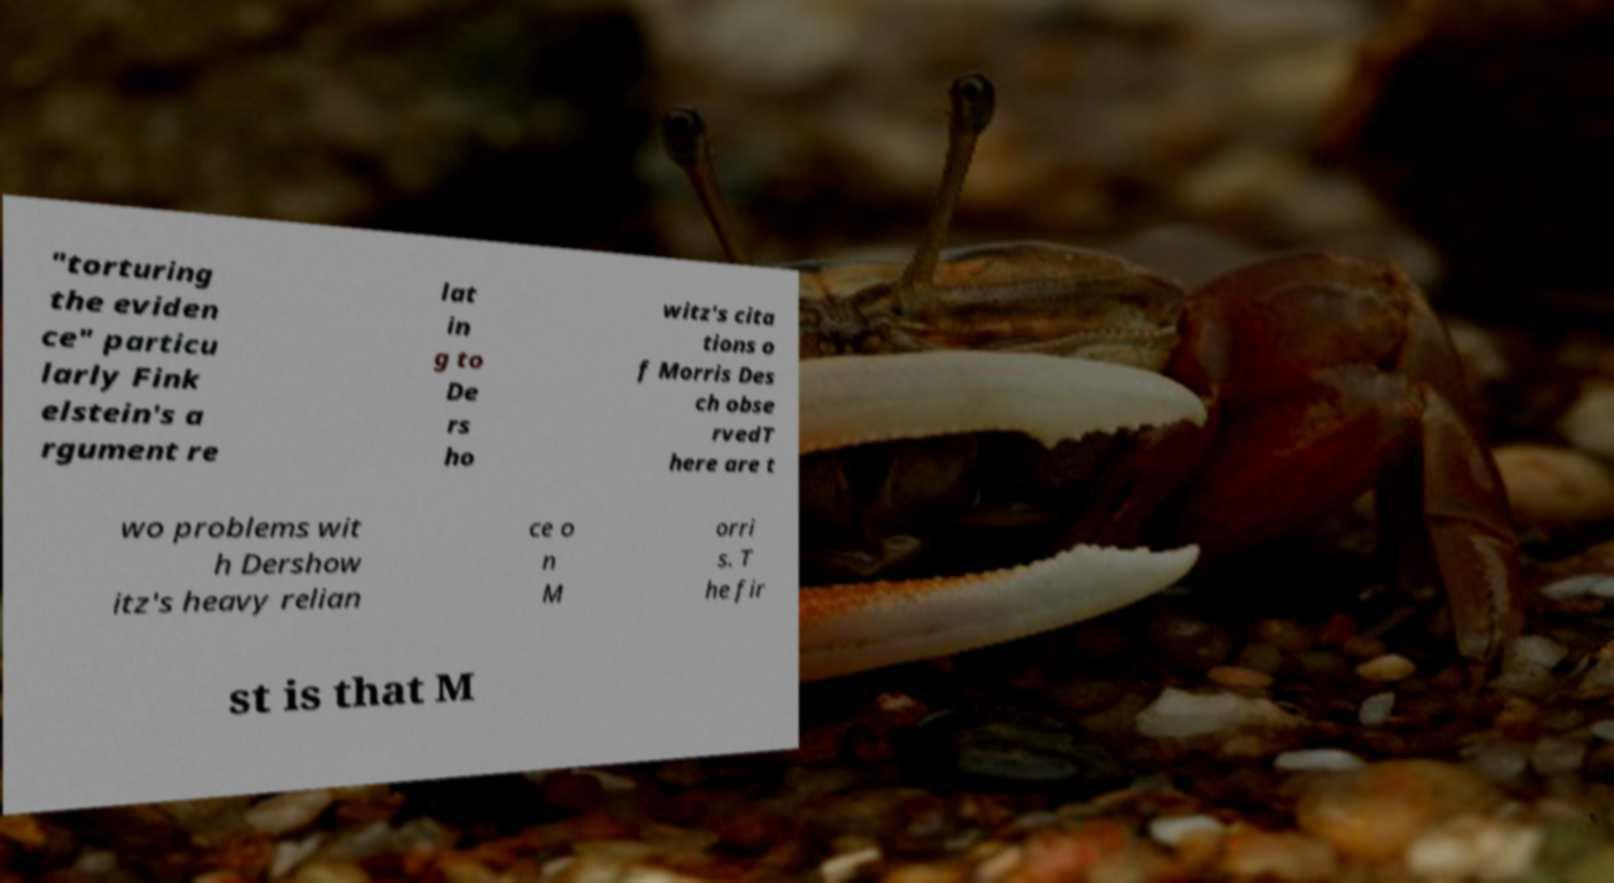Please identify and transcribe the text found in this image. "torturing the eviden ce" particu larly Fink elstein's a rgument re lat in g to De rs ho witz's cita tions o f Morris Des ch obse rvedT here are t wo problems wit h Dershow itz's heavy relian ce o n M orri s. T he fir st is that M 